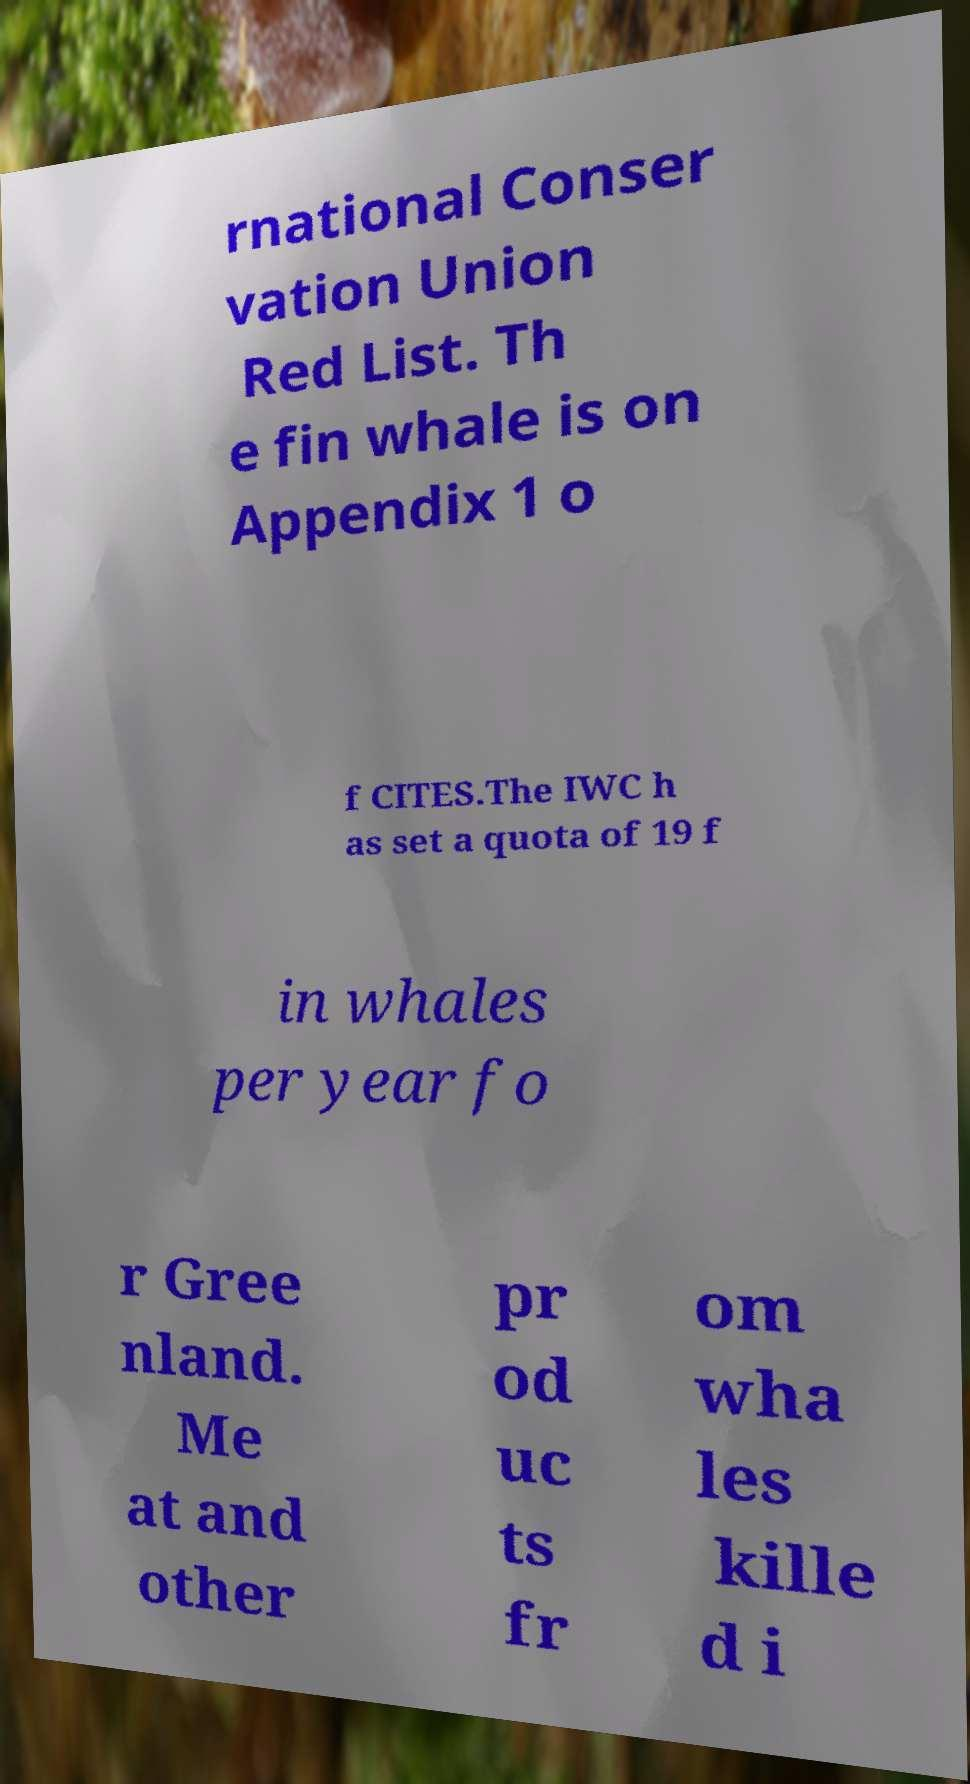What messages or text are displayed in this image? I need them in a readable, typed format. rnational Conser vation Union Red List. Th e fin whale is on Appendix 1 o f CITES.The IWC h as set a quota of 19 f in whales per year fo r Gree nland. Me at and other pr od uc ts fr om wha les kille d i 